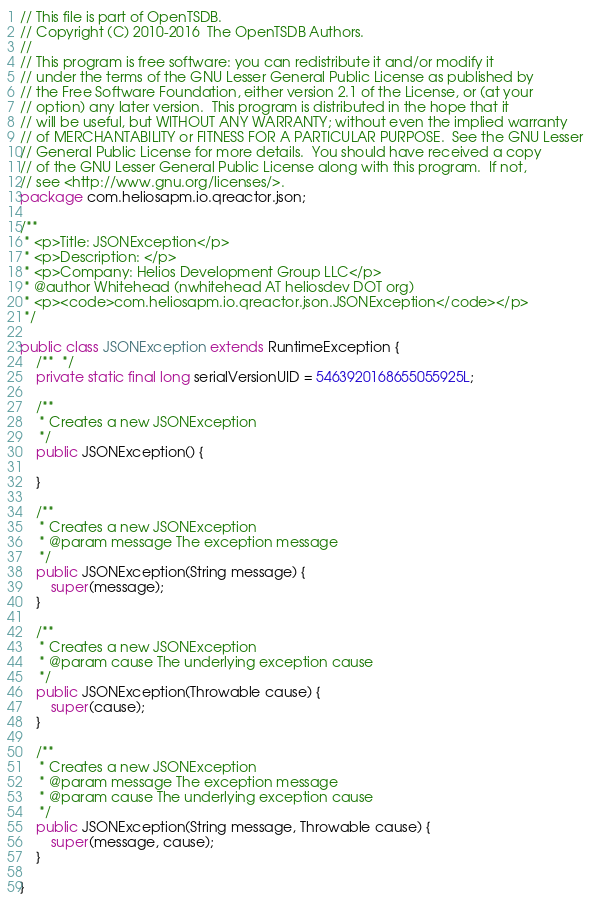<code> <loc_0><loc_0><loc_500><loc_500><_Java_>// This file is part of OpenTSDB.
// Copyright (C) 2010-2016  The OpenTSDB Authors.
//
// This program is free software: you can redistribute it and/or modify it
// under the terms of the GNU Lesser General Public License as published by
// the Free Software Foundation, either version 2.1 of the License, or (at your
// option) any later version.  This program is distributed in the hope that it
// will be useful, but WITHOUT ANY WARRANTY; without even the implied warranty
// of MERCHANTABILITY or FITNESS FOR A PARTICULAR PURPOSE.  See the GNU Lesser
// General Public License for more details.  You should have received a copy
// of the GNU Lesser General Public License along with this program.  If not,
// see <http://www.gnu.org/licenses/>.
package com.heliosapm.io.qreactor.json;

/**
 * <p>Title: JSONException</p>
 * <p>Description: </p> 
 * <p>Company: Helios Development Group LLC</p>
 * @author Whitehead (nwhitehead AT heliosdev DOT org)
 * <p><code>com.heliosapm.io.qreactor.json.JSONException</code></p>
 */

public class JSONException extends RuntimeException {
	/**  */
	private static final long serialVersionUID = 5463920168655055925L;

	/**
	 * Creates a new JSONException
	 */
	public JSONException() {

	}

	/**
	 * Creates a new JSONException
	 * @param message The exception message
	 */
	public JSONException(String message) {
		super(message);
	}

	/**
	 * Creates a new JSONException
	 * @param cause The underlying exception cause
	 */
	public JSONException(Throwable cause) {
		super(cause);
	}

	/**
	 * Creates a new JSONException
	 * @param message The exception message
	 * @param cause The underlying exception cause
	 */
	public JSONException(String message, Throwable cause) {
		super(message, cause);
	}

}
</code> 